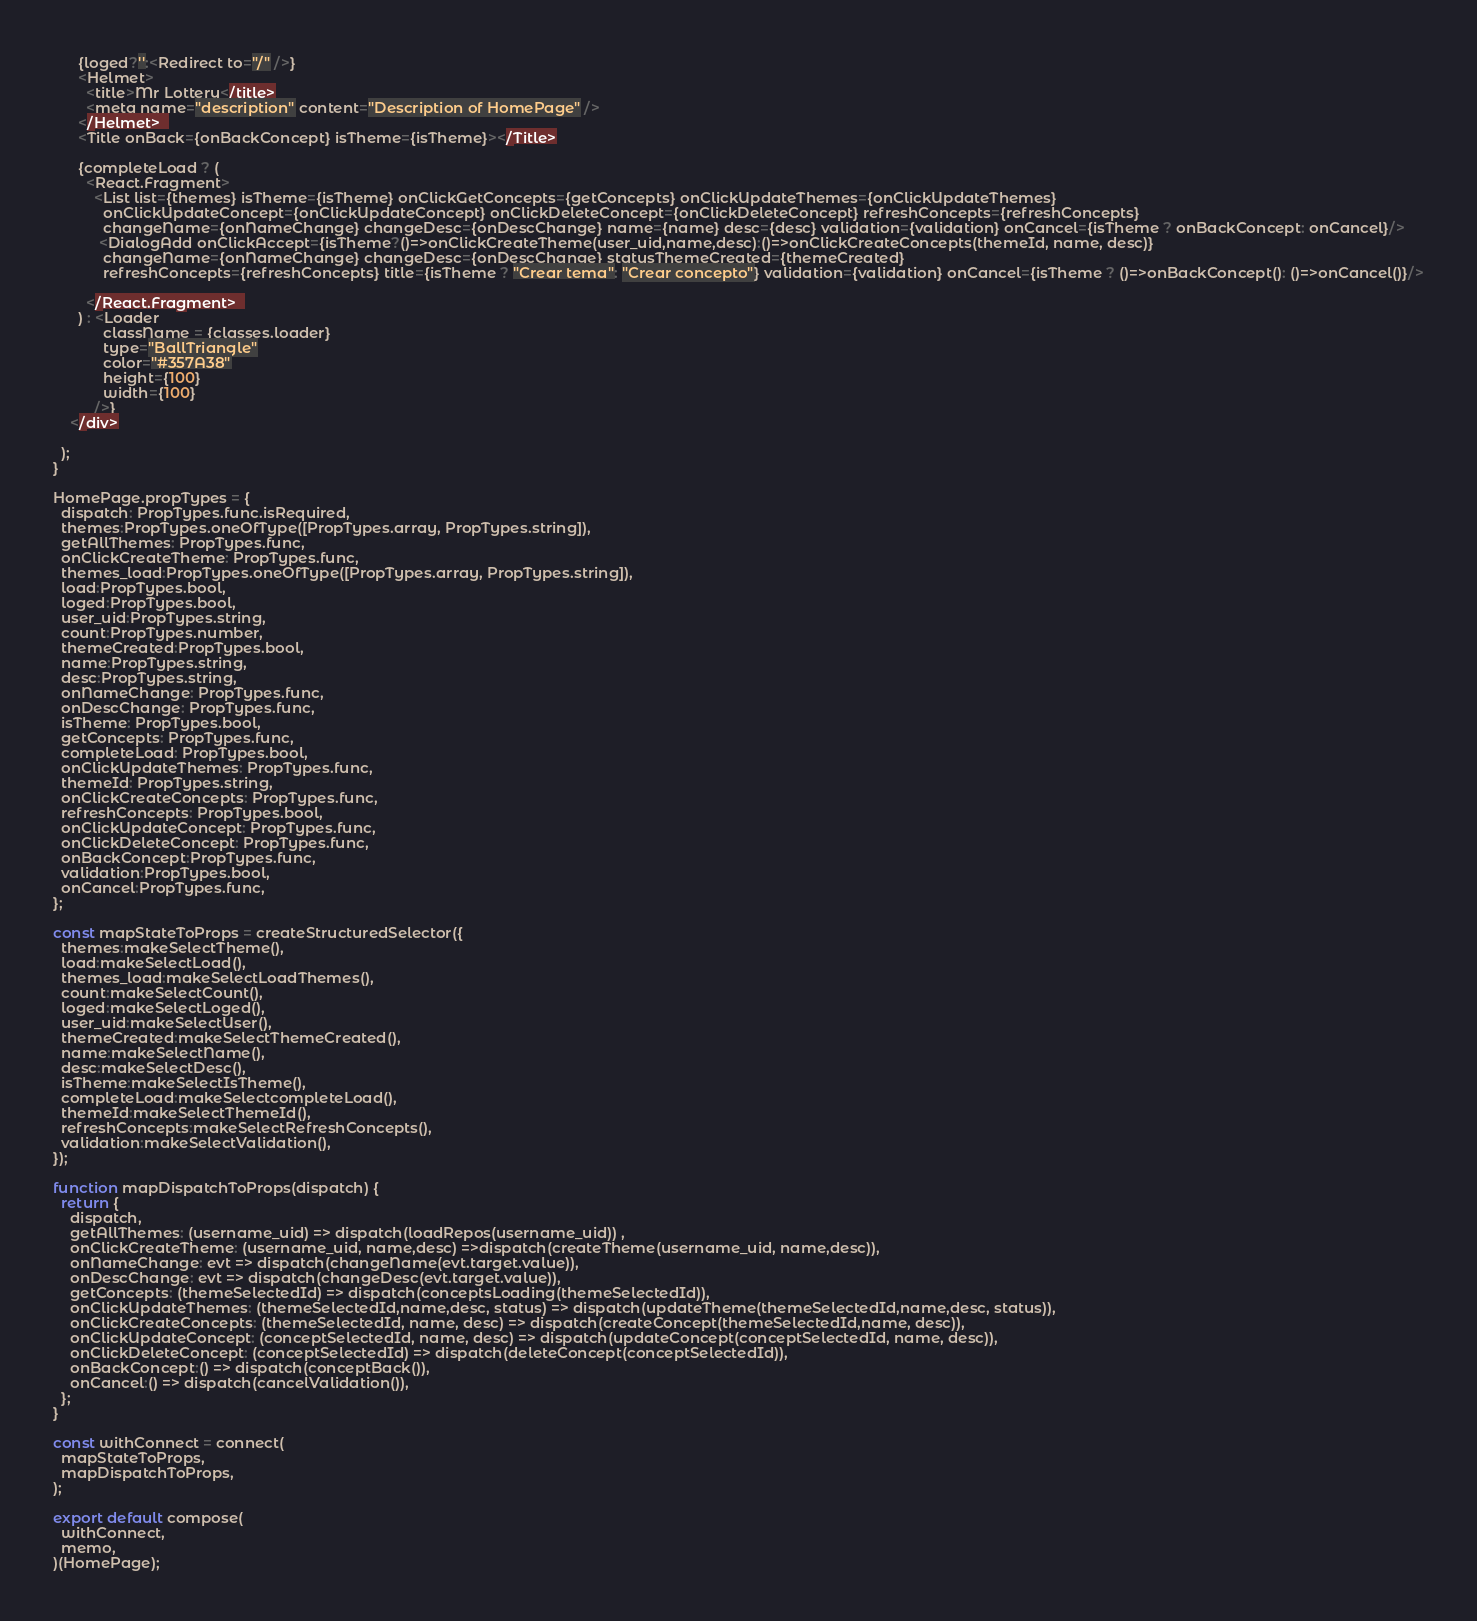Convert code to text. <code><loc_0><loc_0><loc_500><loc_500><_JavaScript_>      {loged?'':<Redirect to="/" />}
      <Helmet>
        <title>Mr Lottery</title>
        <meta name="description" content="Description of HomePage" />
      </Helmet>  
      <Title onBack={onBackConcept} isTheme={isTheme}></Title>

      {completeLoad ? (
        <React.Fragment>
          <List list={themes} isTheme={isTheme} onClickGetConcepts={getConcepts} onClickUpdateThemes={onClickUpdateThemes} 
            onClickUpdateConcept={onClickUpdateConcept} onClickDeleteConcept={onClickDeleteConcept} refreshConcepts={refreshConcepts} 
            changeName={onNameChange} changeDesc={onDescChange} name={name} desc={desc} validation={validation} onCancel={isTheme ? onBackConcept: onCancel}/>
           <DialogAdd onClickAccept={isTheme?()=>onClickCreateTheme(user_uid,name,desc):()=>onClickCreateConcepts(themeId, name, desc)}
            changeName={onNameChange} changeDesc={onDescChange} statusThemeCreated={themeCreated} 
            refreshConcepts={refreshConcepts} title={isTheme ? "Crear tema": "Crear concepto"} validation={validation} onCancel={isTheme ? ()=>onBackConcept(): ()=>onCancel()}/>
          
        </React.Fragment>  
      ) : <Loader
            className = {classes.loader}
            type="BallTriangle"
            color="#357A38"
            height={100}
            width={100}
          />} 
    </div>
    
  );
}

HomePage.propTypes = {
  dispatch: PropTypes.func.isRequired,
  themes:PropTypes.oneOfType([PropTypes.array, PropTypes.string]),
  getAllThemes: PropTypes.func,
  onClickCreateTheme: PropTypes.func,
  themes_load:PropTypes.oneOfType([PropTypes.array, PropTypes.string]),
  load:PropTypes.bool,
  loged:PropTypes.bool,
  user_uid:PropTypes.string,
  count:PropTypes.number,
  themeCreated:PropTypes.bool,
  name:PropTypes.string,
  desc:PropTypes.string,
  onNameChange: PropTypes.func,
  onDescChange: PropTypes.func,
  isTheme: PropTypes.bool,
  getConcepts: PropTypes.func,
  completeLoad: PropTypes.bool,
  onClickUpdateThemes: PropTypes.func,
  themeId: PropTypes.string,
  onClickCreateConcepts: PropTypes.func,
  refreshConcepts: PropTypes.bool,
  onClickUpdateConcept: PropTypes.func,
  onClickDeleteConcept: PropTypes.func,
  onBackConcept:PropTypes.func,
  validation:PropTypes.bool,
  onCancel:PropTypes.func,
};

const mapStateToProps = createStructuredSelector({
  themes:makeSelectTheme(),
  load:makeSelectLoad(),
  themes_load:makeSelectLoadThemes(),
  count:makeSelectCount(),
  loged:makeSelectLoged(),
  user_uid:makeSelectUser(),
  themeCreated:makeSelectThemeCreated(),
  name:makeSelectName(),
  desc:makeSelectDesc(),
  isTheme:makeSelectIsTheme(),
  completeLoad:makeSelectcompleteLoad(),
  themeId:makeSelectThemeId(),
  refreshConcepts:makeSelectRefreshConcepts(),
  validation:makeSelectValidation(),
});

function mapDispatchToProps(dispatch) {
  return {
    dispatch,
    getAllThemes: (username_uid) => dispatch(loadRepos(username_uid)) ,
    onClickCreateTheme: (username_uid, name,desc) =>dispatch(createTheme(username_uid, name,desc)),
    onNameChange: evt => dispatch(changeName(evt.target.value)),
    onDescChange: evt => dispatch(changeDesc(evt.target.value)),
    getConcepts: (themeSelectedId) => dispatch(conceptsLoading(themeSelectedId)),
    onClickUpdateThemes: (themeSelectedId,name,desc, status) => dispatch(updateTheme(themeSelectedId,name,desc, status)),
    onClickCreateConcepts: (themeSelectedId, name, desc) => dispatch(createConcept(themeSelectedId,name, desc)),
    onClickUpdateConcept: (conceptSelectedId, name, desc) => dispatch(updateConcept(conceptSelectedId, name, desc)),
    onClickDeleteConcept: (conceptSelectedId) => dispatch(deleteConcept(conceptSelectedId)),
    onBackConcept:() => dispatch(conceptBack()),
    onCancel:() => dispatch(cancelValidation()),
  };
}

const withConnect = connect(
  mapStateToProps,
  mapDispatchToProps,
);

export default compose(
  withConnect,
  memo,
)(HomePage);
</code> 